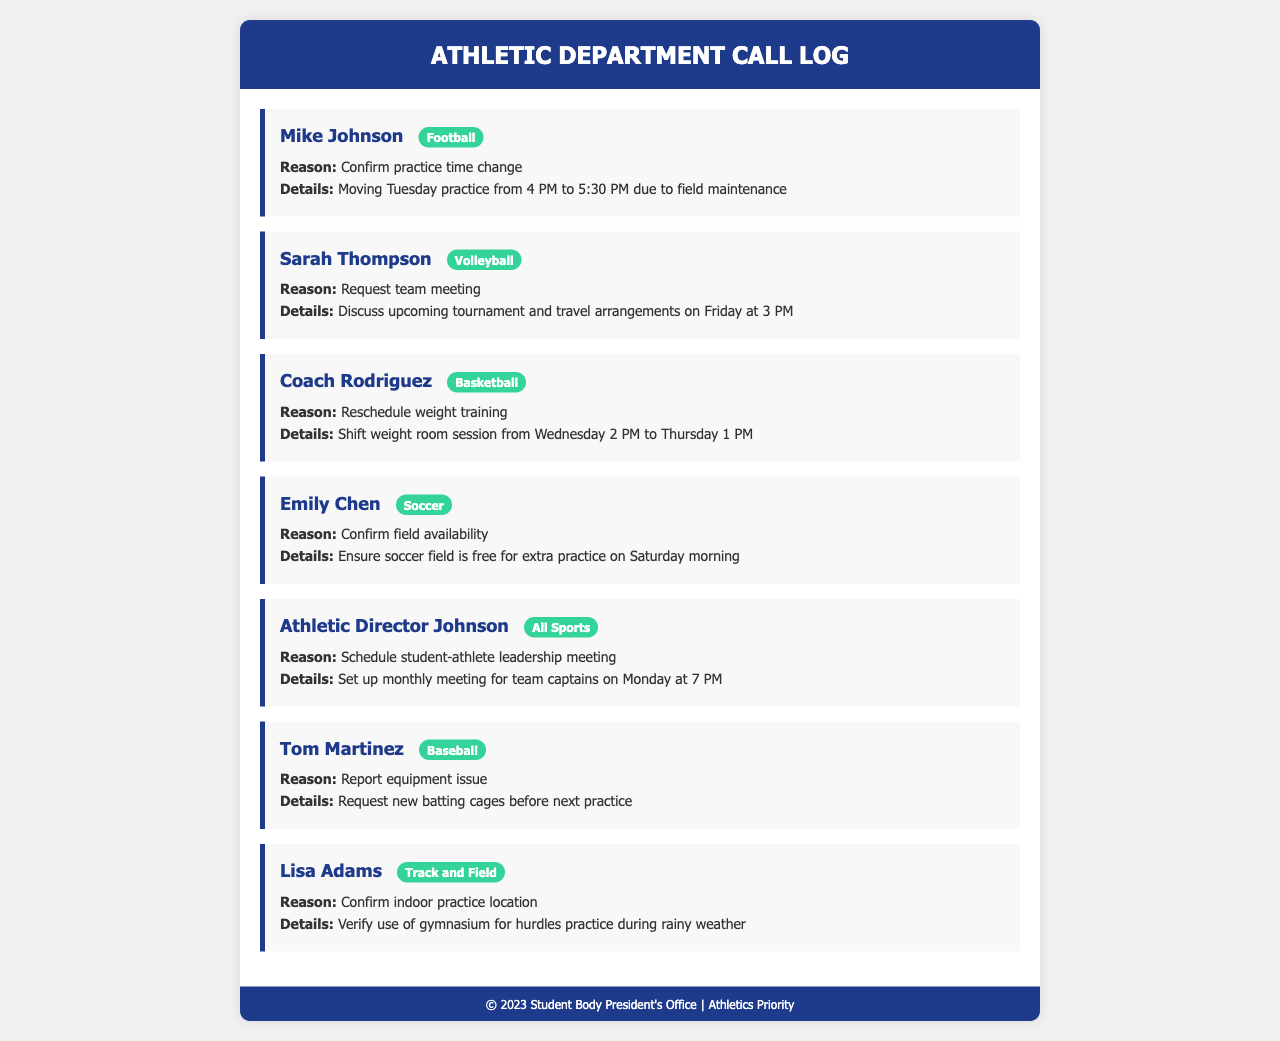What is the name of the first caller? The first caller listed in the document is Mike Johnson.
Answer: Mike Johnson What sport is Sarah Thompson associated with? Sarah Thompson is identified with the Volleyball sport tag.
Answer: Volleyball What change did Coach Rodriguez request? Coach Rodriguez requested to shift the weight room session from Wednesday to Thursday.
Answer: Reschedule weight training What time is the student-athlete leadership meeting scheduled for? The leadership meeting is set for Monday at 7 PM.
Answer: 7 PM Which caller reported an equipment issue? The caller who reported an equipment issue is Tom Martinez.
Answer: Tom Martinez What is the main reason for Emily Chen's call? Emily Chen's call mainly seeks to confirm field availability for extra practice.
Answer: Confirm field availability Which team is Lisa Adams part of? Lisa Adams is part of the Track and Field team.
Answer: Track and Field On what day is the volleyball team's meeting planned? The volleyball team's meeting is planned for Friday.
Answer: Friday What issue did Tom Martinez address in his call? Tom Martinez addressed the need for new batting cages before the next practice.
Answer: Equipment issue 